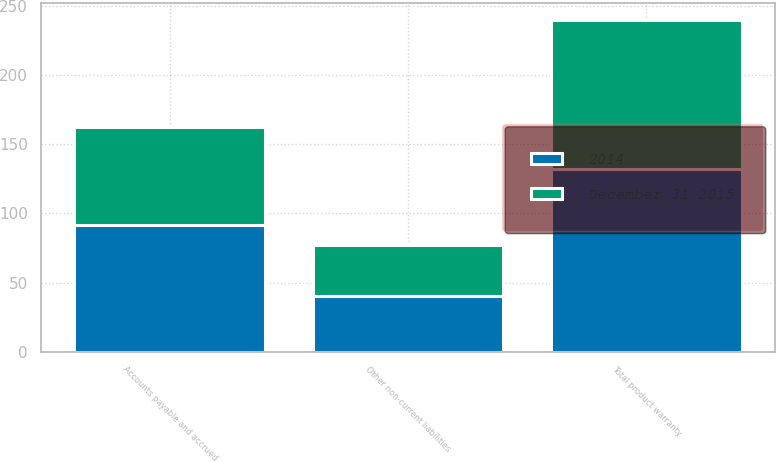Convert chart to OTSL. <chart><loc_0><loc_0><loc_500><loc_500><stacked_bar_chart><ecel><fcel>Accounts payable and accrued<fcel>Other non-current liabilities<fcel>Total product warranty<nl><fcel>December 31 2015<fcel>70.6<fcel>37.3<fcel>107.9<nl><fcel>2014<fcel>91.9<fcel>40.1<fcel>132<nl></chart> 